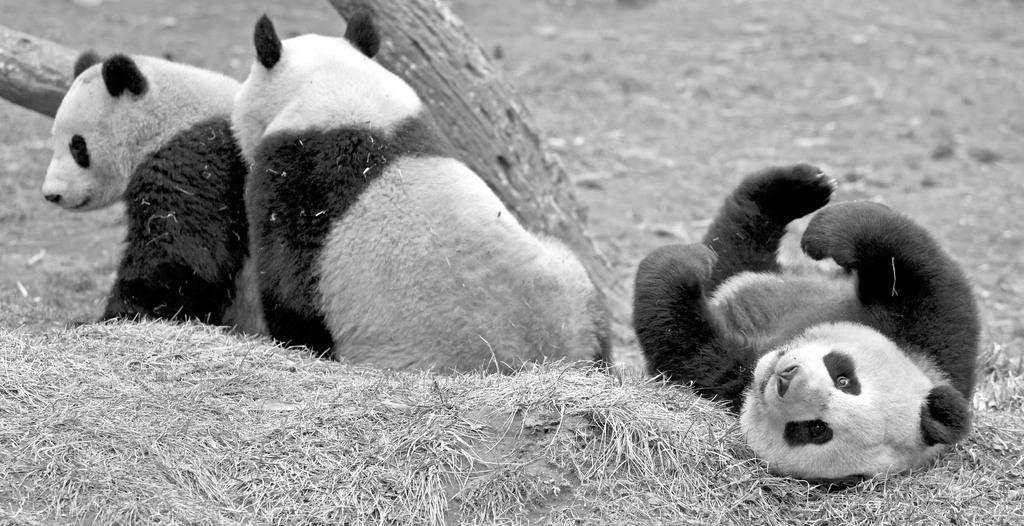In one or two sentences, can you explain what this image depicts? This image is a black and white image. This image is taken outdoors. At the bottom of the image there is a ground with grass on it. In the background there is a bark of a tree. In the middle of the image there are three pandas on the ground. 